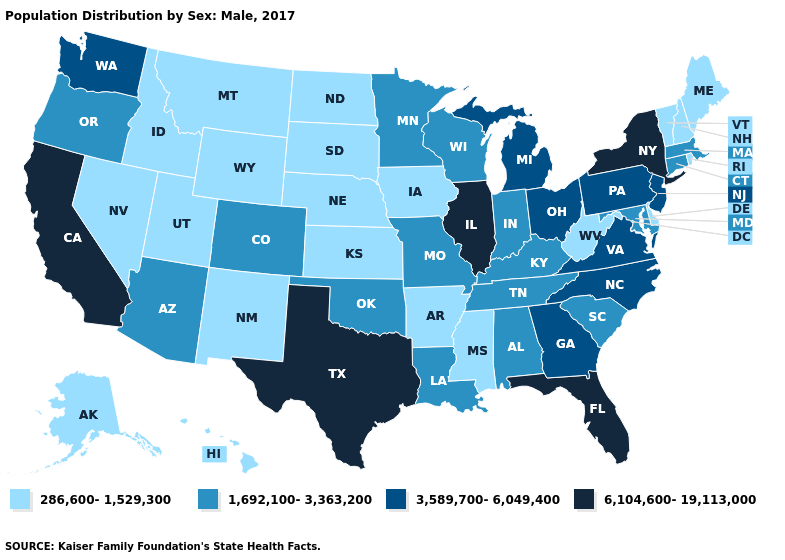Name the states that have a value in the range 6,104,600-19,113,000?
Keep it brief. California, Florida, Illinois, New York, Texas. Does Alaska have the highest value in the USA?
Short answer required. No. What is the lowest value in the Northeast?
Keep it brief. 286,600-1,529,300. Does Montana have a higher value than Rhode Island?
Write a very short answer. No. Name the states that have a value in the range 3,589,700-6,049,400?
Be succinct. Georgia, Michigan, New Jersey, North Carolina, Ohio, Pennsylvania, Virginia, Washington. Among the states that border Iowa , does Illinois have the highest value?
Give a very brief answer. Yes. Which states have the highest value in the USA?
Concise answer only. California, Florida, Illinois, New York, Texas. What is the value of Arizona?
Answer briefly. 1,692,100-3,363,200. What is the highest value in the Northeast ?
Short answer required. 6,104,600-19,113,000. Name the states that have a value in the range 1,692,100-3,363,200?
Keep it brief. Alabama, Arizona, Colorado, Connecticut, Indiana, Kentucky, Louisiana, Maryland, Massachusetts, Minnesota, Missouri, Oklahoma, Oregon, South Carolina, Tennessee, Wisconsin. Name the states that have a value in the range 1,692,100-3,363,200?
Give a very brief answer. Alabama, Arizona, Colorado, Connecticut, Indiana, Kentucky, Louisiana, Maryland, Massachusetts, Minnesota, Missouri, Oklahoma, Oregon, South Carolina, Tennessee, Wisconsin. Does Texas have the lowest value in the South?
Concise answer only. No. Name the states that have a value in the range 1,692,100-3,363,200?
Answer briefly. Alabama, Arizona, Colorado, Connecticut, Indiana, Kentucky, Louisiana, Maryland, Massachusetts, Minnesota, Missouri, Oklahoma, Oregon, South Carolina, Tennessee, Wisconsin. Which states have the lowest value in the West?
Concise answer only. Alaska, Hawaii, Idaho, Montana, Nevada, New Mexico, Utah, Wyoming. What is the value of New Mexico?
Answer briefly. 286,600-1,529,300. 